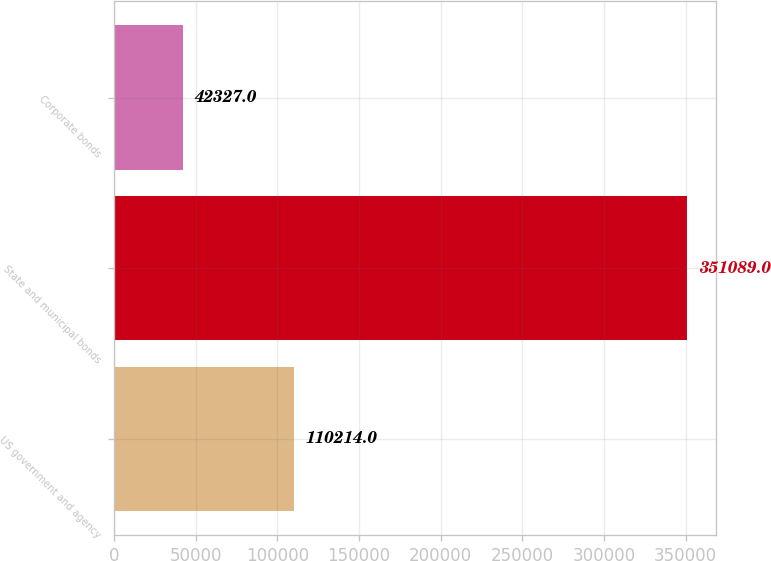Convert chart to OTSL. <chart><loc_0><loc_0><loc_500><loc_500><bar_chart><fcel>US government and agency<fcel>State and municipal bonds<fcel>Corporate bonds<nl><fcel>110214<fcel>351089<fcel>42327<nl></chart> 